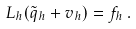<formula> <loc_0><loc_0><loc_500><loc_500>L _ { h } ( \tilde { q } _ { h } + v _ { h } ) = f _ { h } \, .</formula> 